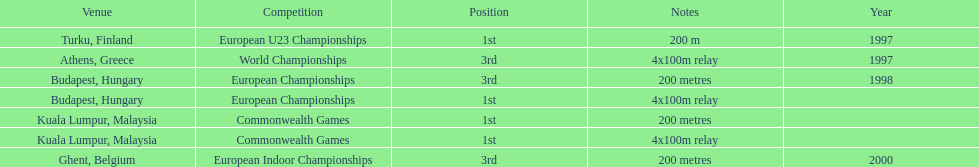How many events were won in malaysia? 2. 